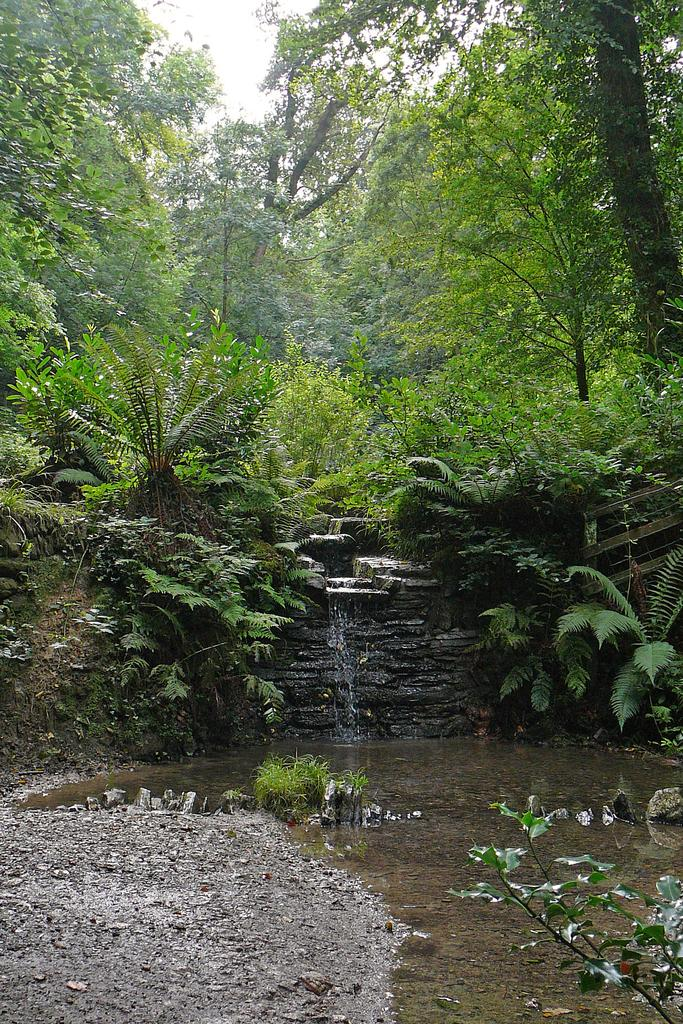What is the main feature in the center of the image? There is a waterfall in the center of the image. What can be seen in the background of the image? There are trees in the background of the image. What type of terrain is visible to the left side of the image? There is mud to the left side of the image. What type of mark can be seen on the quilt in the image? There is no quilt present in the image, so it is not possible to determine if there is a mark on it. 